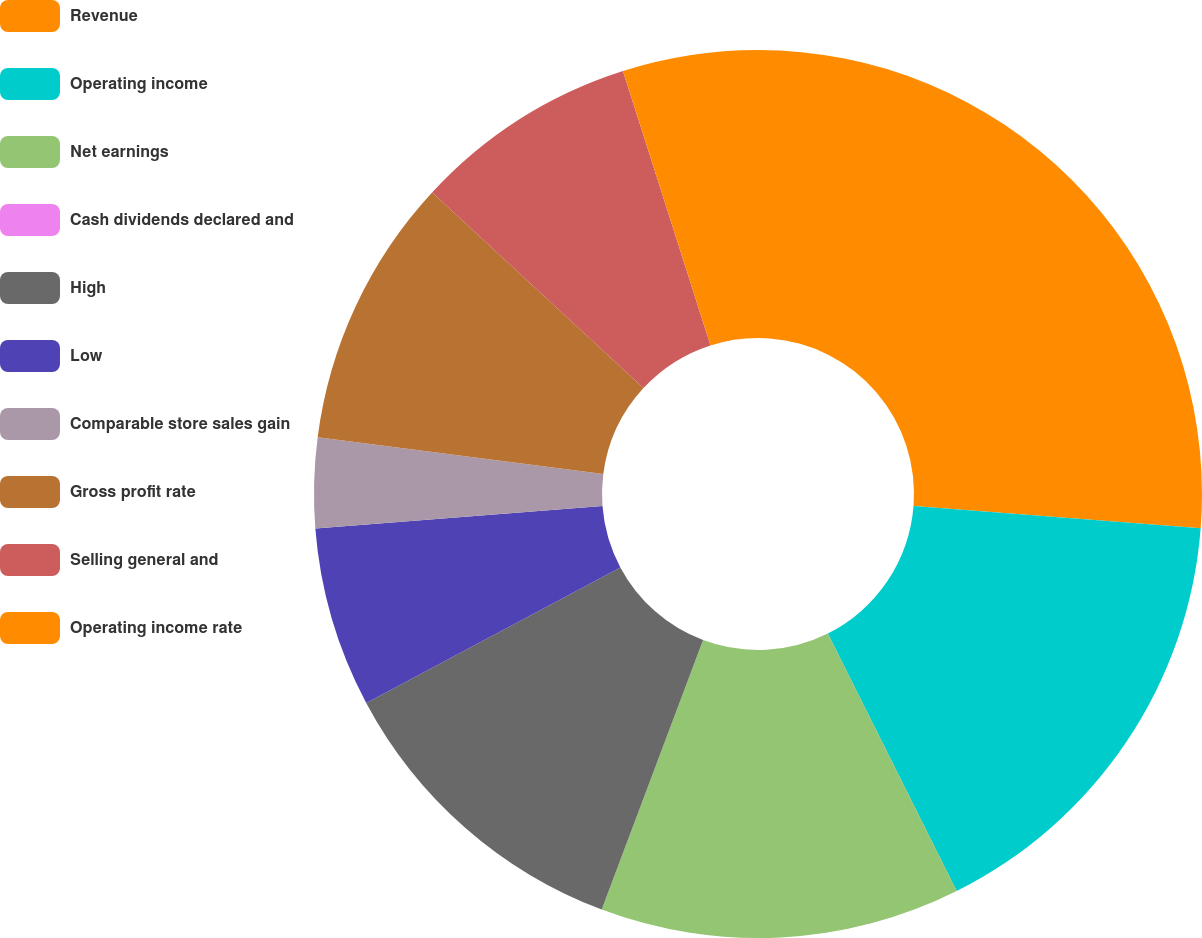Convert chart. <chart><loc_0><loc_0><loc_500><loc_500><pie_chart><fcel>Revenue<fcel>Operating income<fcel>Net earnings<fcel>Cash dividends declared and<fcel>High<fcel>Low<fcel>Comparable store sales gain<fcel>Gross profit rate<fcel>Selling general and<fcel>Operating income rate<nl><fcel>26.23%<fcel>16.39%<fcel>13.11%<fcel>0.0%<fcel>11.48%<fcel>6.56%<fcel>3.28%<fcel>9.84%<fcel>8.2%<fcel>4.92%<nl></chart> 